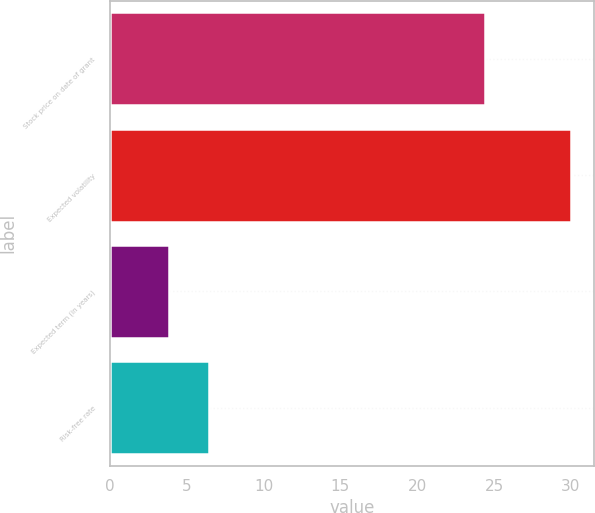Convert chart. <chart><loc_0><loc_0><loc_500><loc_500><bar_chart><fcel>Stock price on date of grant<fcel>Expected volatility<fcel>Expected term (in years)<fcel>Risk-free rate<nl><fcel>24.42<fcel>30<fcel>3.84<fcel>6.46<nl></chart> 